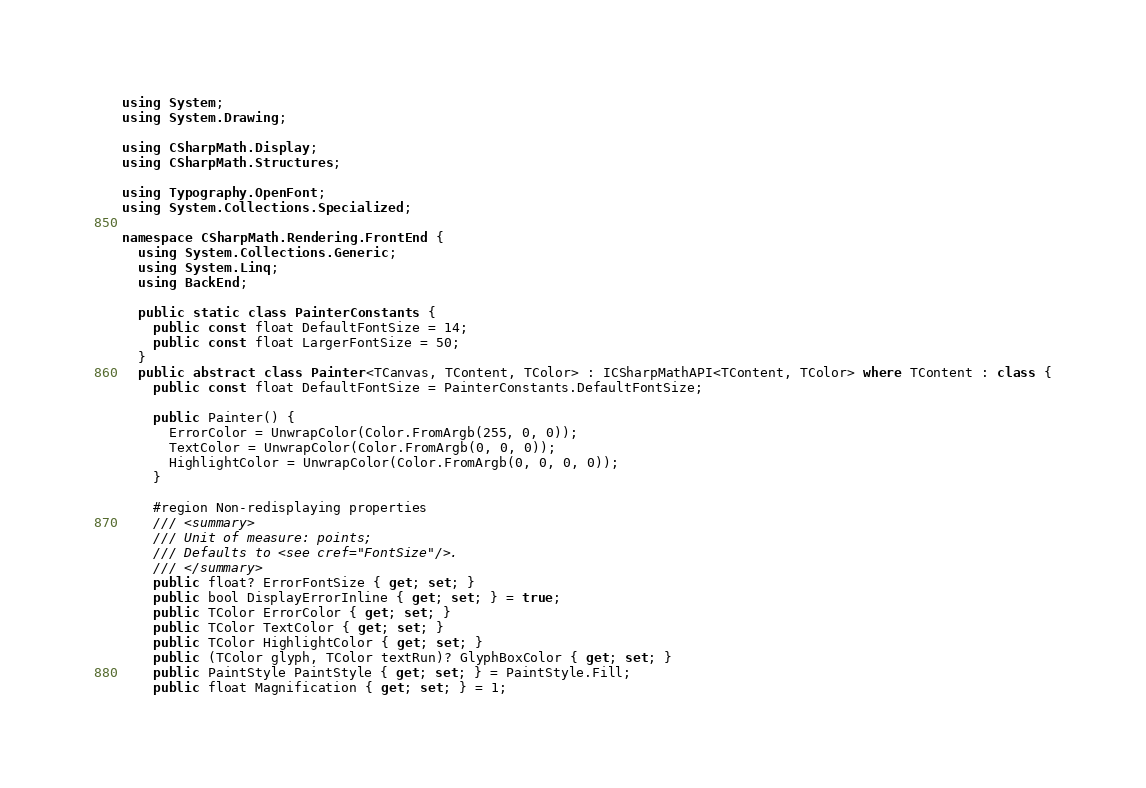<code> <loc_0><loc_0><loc_500><loc_500><_C#_>using System;
using System.Drawing;

using CSharpMath.Display;
using CSharpMath.Structures;

using Typography.OpenFont;
using System.Collections.Specialized;

namespace CSharpMath.Rendering.FrontEnd {
  using System.Collections.Generic;
  using System.Linq;
  using BackEnd;

  public static class PainterConstants {
    public const float DefaultFontSize = 14;
    public const float LargerFontSize = 50;
  }
  public abstract class Painter<TCanvas, TContent, TColor> : ICSharpMathAPI<TContent, TColor> where TContent : class {
    public const float DefaultFontSize = PainterConstants.DefaultFontSize;

    public Painter() {
      ErrorColor = UnwrapColor(Color.FromArgb(255, 0, 0));
      TextColor = UnwrapColor(Color.FromArgb(0, 0, 0));
      HighlightColor = UnwrapColor(Color.FromArgb(0, 0, 0, 0));
    }

    #region Non-redisplaying properties
    /// <summary>
    /// Unit of measure: points;
    /// Defaults to <see cref="FontSize"/>.
    /// </summary>
    public float? ErrorFontSize { get; set; }
    public bool DisplayErrorInline { get; set; } = true;
    public TColor ErrorColor { get; set; }
    public TColor TextColor { get; set; }
    public TColor HighlightColor { get; set; }
    public (TColor glyph, TColor textRun)? GlyphBoxColor { get; set; }
    public PaintStyle PaintStyle { get; set; } = PaintStyle.Fill;
    public float Magnification { get; set; } = 1;</code> 